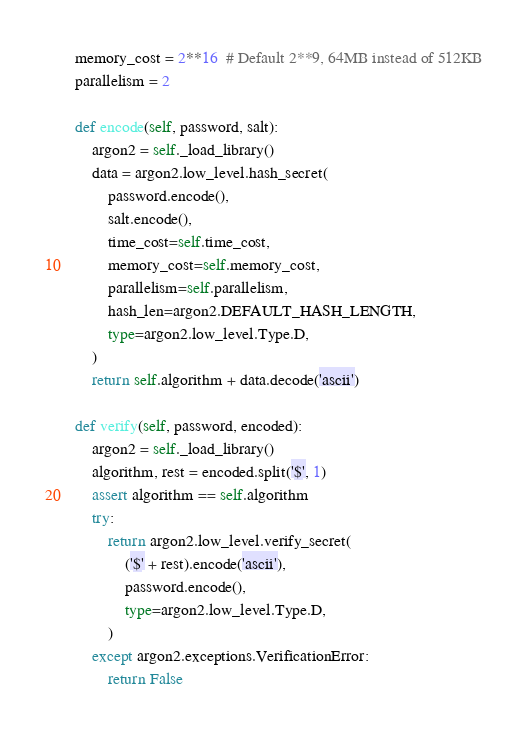<code> <loc_0><loc_0><loc_500><loc_500><_Python_>    memory_cost = 2**16  # Default 2**9, 64MB instead of 512KB
    parallelism = 2

    def encode(self, password, salt):
        argon2 = self._load_library()
        data = argon2.low_level.hash_secret(
            password.encode(),
            salt.encode(),
            time_cost=self.time_cost,
            memory_cost=self.memory_cost,
            parallelism=self.parallelism,
            hash_len=argon2.DEFAULT_HASH_LENGTH,
            type=argon2.low_level.Type.D,
        )
        return self.algorithm + data.decode('ascii')

    def verify(self, password, encoded):
        argon2 = self._load_library()
        algorithm, rest = encoded.split('$', 1)
        assert algorithm == self.algorithm
        try:
            return argon2.low_level.verify_secret(
                ('$' + rest).encode('ascii'),
                password.encode(),
                type=argon2.low_level.Type.D,
            )
        except argon2.exceptions.VerificationError:
            return False
</code> 